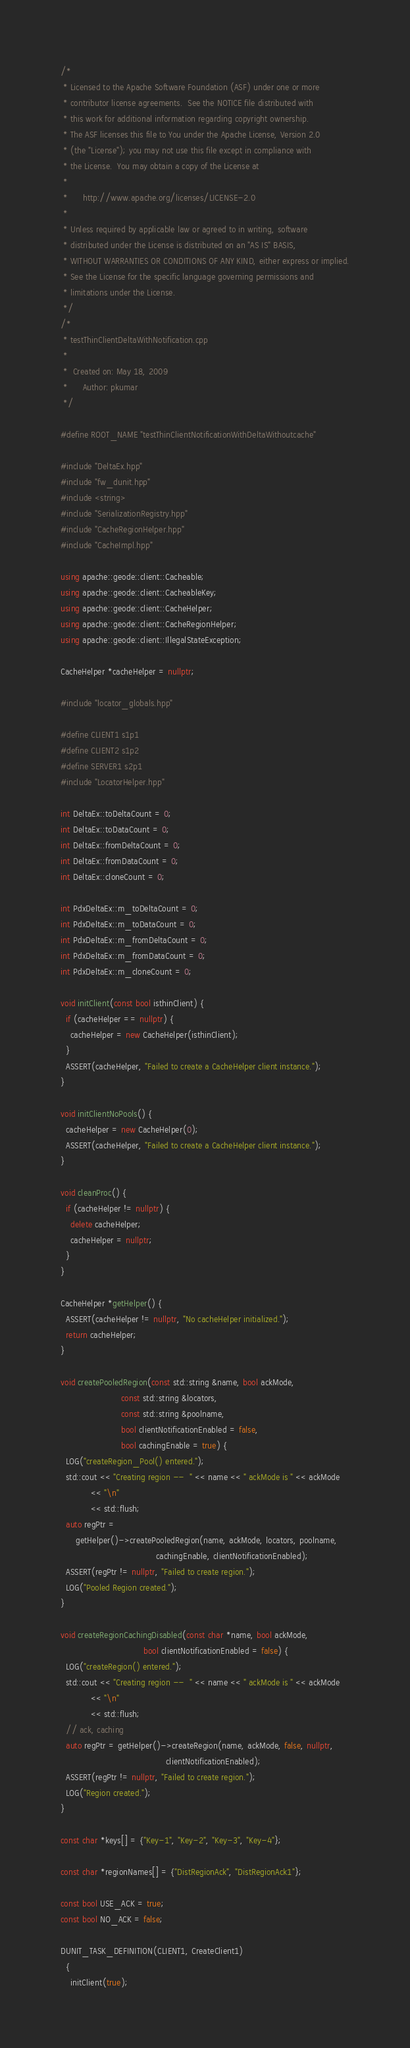Convert code to text. <code><loc_0><loc_0><loc_500><loc_500><_C++_>/*
 * Licensed to the Apache Software Foundation (ASF) under one or more
 * contributor license agreements.  See the NOTICE file distributed with
 * this work for additional information regarding copyright ownership.
 * The ASF licenses this file to You under the Apache License, Version 2.0
 * (the "License"); you may not use this file except in compliance with
 * the License.  You may obtain a copy of the License at
 *
 *      http://www.apache.org/licenses/LICENSE-2.0
 *
 * Unless required by applicable law or agreed to in writing, software
 * distributed under the License is distributed on an "AS IS" BASIS,
 * WITHOUT WARRANTIES OR CONDITIONS OF ANY KIND, either express or implied.
 * See the License for the specific language governing permissions and
 * limitations under the License.
 */
/*
 * testThinClientDeltaWithNotification.cpp
 *
 *  Created on: May 18, 2009
 *      Author: pkumar
 */

#define ROOT_NAME "testThinClientNotificationWithDeltaWithoutcache"

#include "DeltaEx.hpp"
#include "fw_dunit.hpp"
#include <string>
#include "SerializationRegistry.hpp"
#include "CacheRegionHelper.hpp"
#include "CacheImpl.hpp"

using apache::geode::client::Cacheable;
using apache::geode::client::CacheableKey;
using apache::geode::client::CacheHelper;
using apache::geode::client::CacheRegionHelper;
using apache::geode::client::IllegalStateException;

CacheHelper *cacheHelper = nullptr;

#include "locator_globals.hpp"

#define CLIENT1 s1p1
#define CLIENT2 s1p2
#define SERVER1 s2p1
#include "LocatorHelper.hpp"

int DeltaEx::toDeltaCount = 0;
int DeltaEx::toDataCount = 0;
int DeltaEx::fromDeltaCount = 0;
int DeltaEx::fromDataCount = 0;
int DeltaEx::cloneCount = 0;

int PdxDeltaEx::m_toDeltaCount = 0;
int PdxDeltaEx::m_toDataCount = 0;
int PdxDeltaEx::m_fromDeltaCount = 0;
int PdxDeltaEx::m_fromDataCount = 0;
int PdxDeltaEx::m_cloneCount = 0;

void initClient(const bool isthinClient) {
  if (cacheHelper == nullptr) {
    cacheHelper = new CacheHelper(isthinClient);
  }
  ASSERT(cacheHelper, "Failed to create a CacheHelper client instance.");
}

void initClientNoPools() {
  cacheHelper = new CacheHelper(0);
  ASSERT(cacheHelper, "Failed to create a CacheHelper client instance.");
}

void cleanProc() {
  if (cacheHelper != nullptr) {
    delete cacheHelper;
    cacheHelper = nullptr;
  }
}

CacheHelper *getHelper() {
  ASSERT(cacheHelper != nullptr, "No cacheHelper initialized.");
  return cacheHelper;
}

void createPooledRegion(const std::string &name, bool ackMode,
                        const std::string &locators,
                        const std::string &poolname,
                        bool clientNotificationEnabled = false,
                        bool cachingEnable = true) {
  LOG("createRegion_Pool() entered.");
  std::cout << "Creating region --  " << name << " ackMode is " << ackMode
            << "\n"
            << std::flush;
  auto regPtr =
      getHelper()->createPooledRegion(name, ackMode, locators, poolname,
                                      cachingEnable, clientNotificationEnabled);
  ASSERT(regPtr != nullptr, "Failed to create region.");
  LOG("Pooled Region created.");
}

void createRegionCachingDisabled(const char *name, bool ackMode,
                                 bool clientNotificationEnabled = false) {
  LOG("createRegion() entered.");
  std::cout << "Creating region --  " << name << " ackMode is " << ackMode
            << "\n"
            << std::flush;
  // ack, caching
  auto regPtr = getHelper()->createRegion(name, ackMode, false, nullptr,
                                          clientNotificationEnabled);
  ASSERT(regPtr != nullptr, "Failed to create region.");
  LOG("Region created.");
}

const char *keys[] = {"Key-1", "Key-2", "Key-3", "Key-4"};

const char *regionNames[] = {"DistRegionAck", "DistRegionAck1"};

const bool USE_ACK = true;
const bool NO_ACK = false;

DUNIT_TASK_DEFINITION(CLIENT1, CreateClient1)
  {
    initClient(true);</code> 